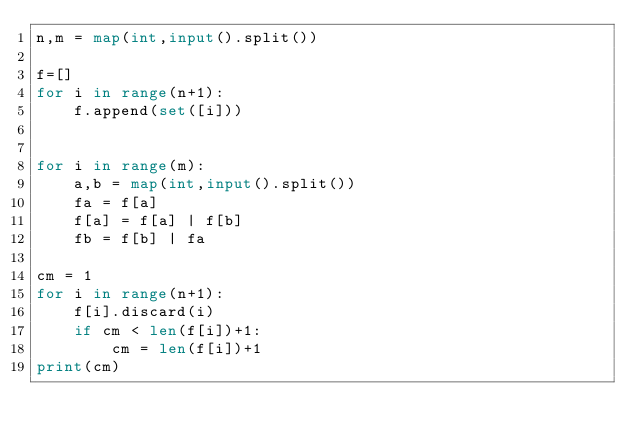<code> <loc_0><loc_0><loc_500><loc_500><_Python_>n,m = map(int,input().split())

f=[]
for i in range(n+1):
    f.append(set([i]))


for i in range(m):
    a,b = map(int,input().split())
    fa = f[a]
    f[a] = f[a] | f[b]      
    fb = f[b] | fa

cm = 1
for i in range(n+1):
    f[i].discard(i)
    if cm < len(f[i])+1:
        cm = len(f[i])+1
print(cm)
</code> 